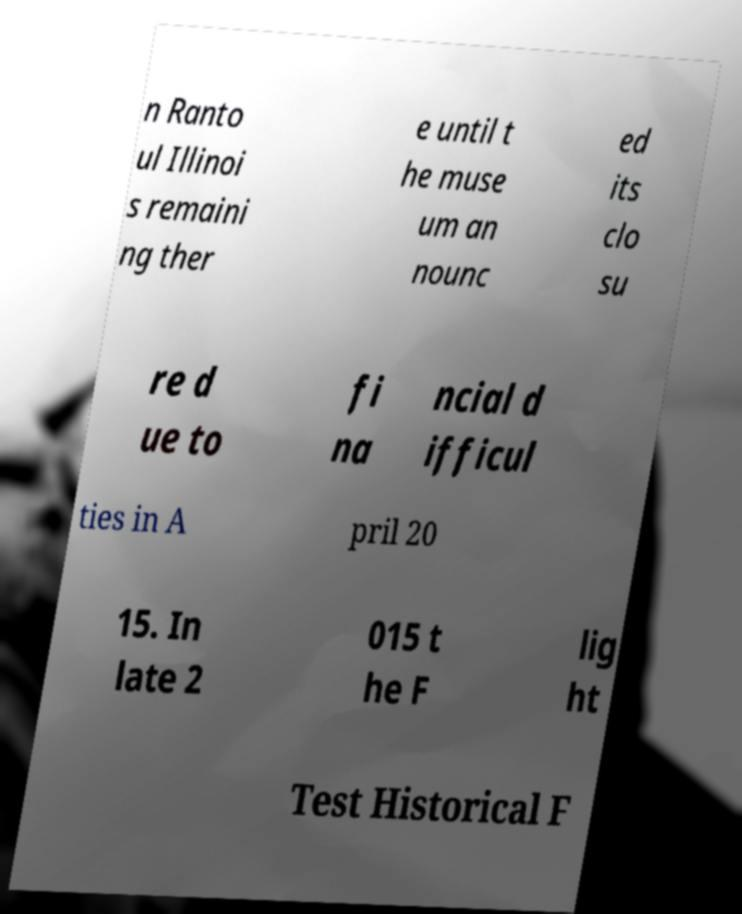Could you assist in decoding the text presented in this image and type it out clearly? n Ranto ul Illinoi s remaini ng ther e until t he muse um an nounc ed its clo su re d ue to fi na ncial d ifficul ties in A pril 20 15. In late 2 015 t he F lig ht Test Historical F 